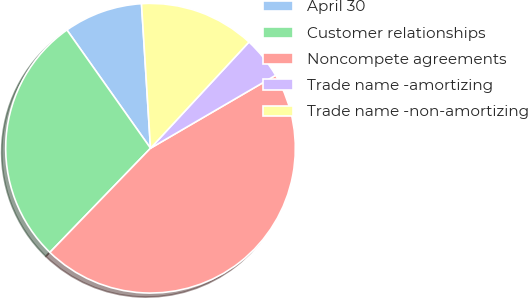Convert chart. <chart><loc_0><loc_0><loc_500><loc_500><pie_chart><fcel>April 30<fcel>Customer relationships<fcel>Noncompete agreements<fcel>Trade name -amortizing<fcel>Trade name -non-amortizing<nl><fcel>8.8%<fcel>27.98%<fcel>45.63%<fcel>4.7%<fcel>12.89%<nl></chart> 